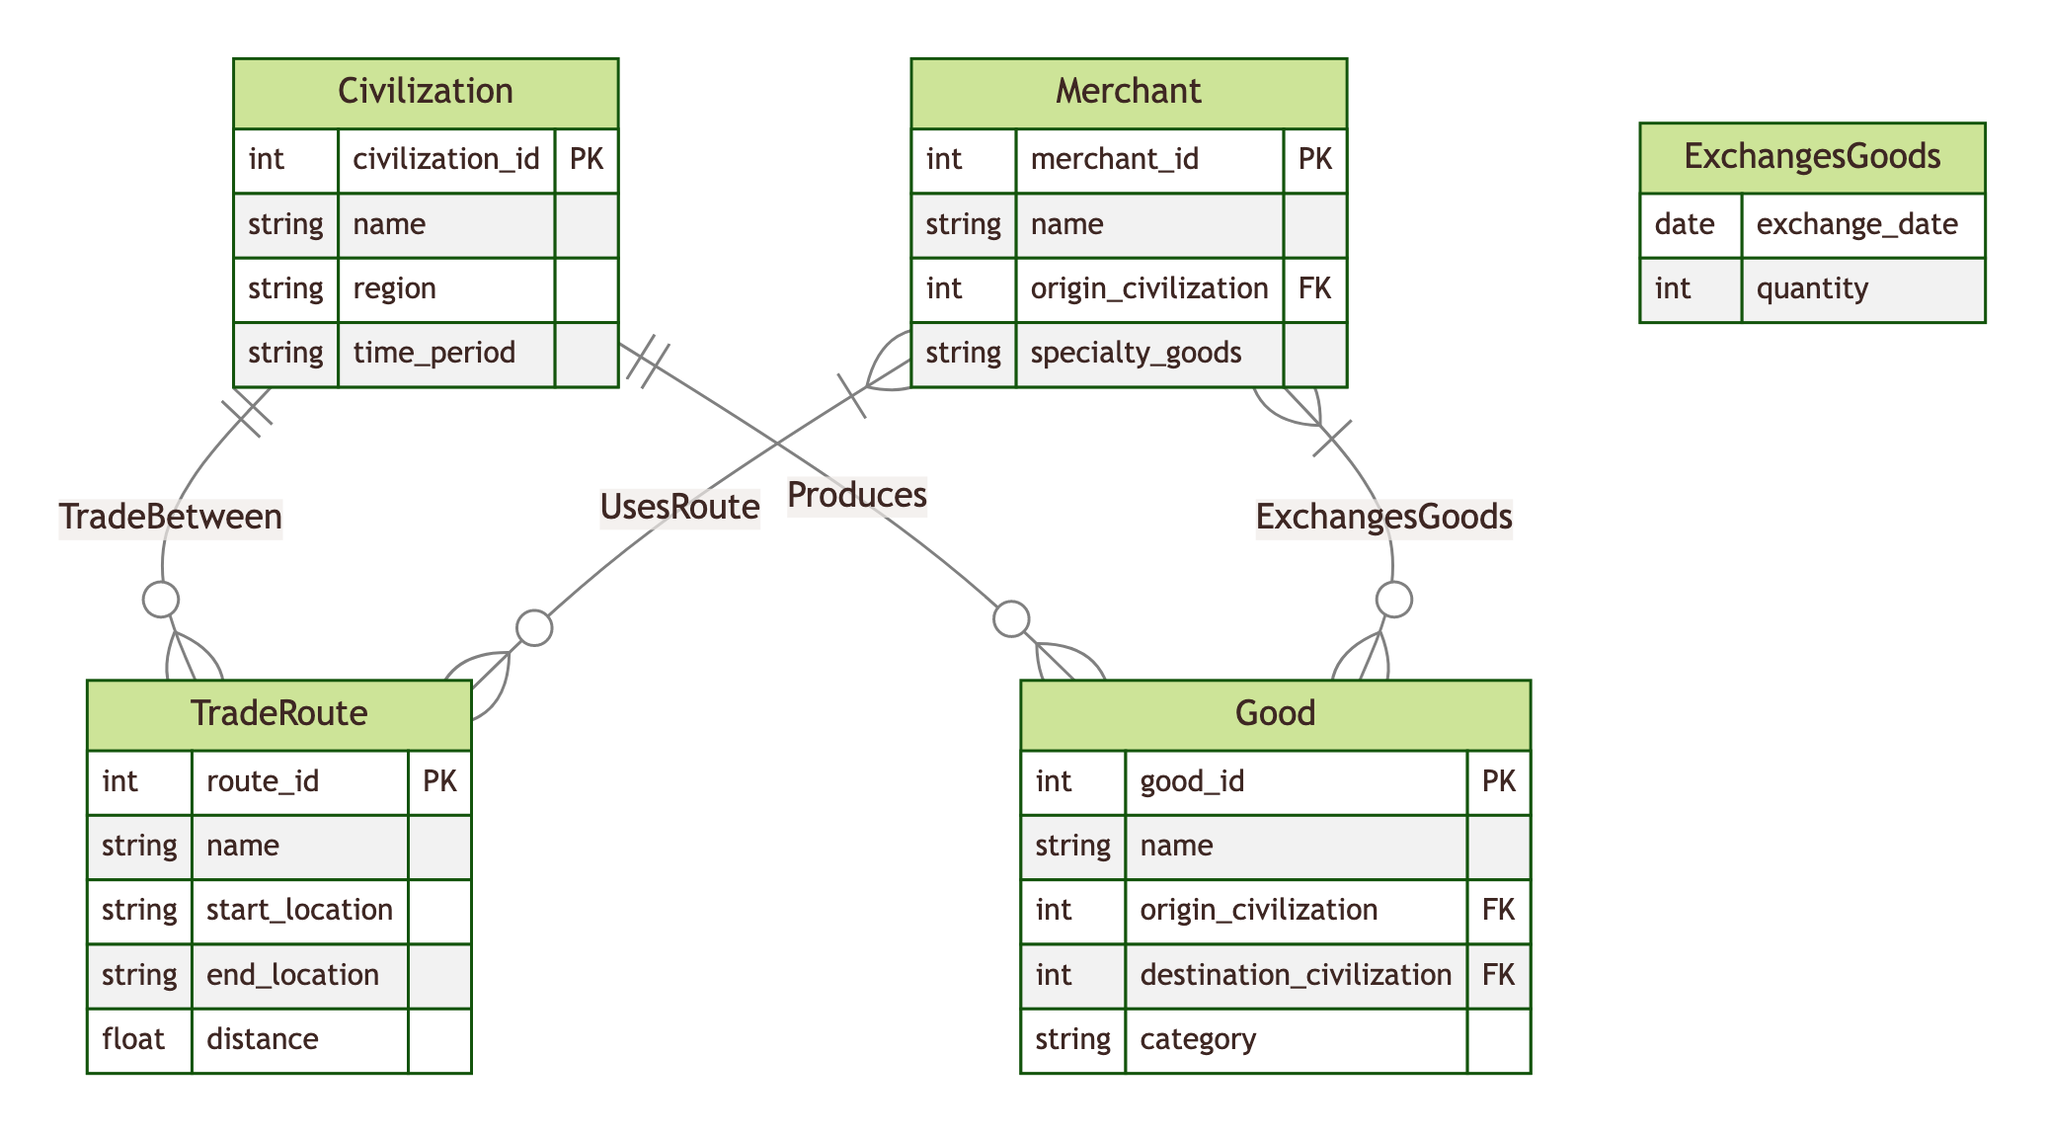What entities are present in the diagram? The diagram contains four entities: Civilization, TradeRoute, Merchant, and Good.
Answer: Civilization, TradeRoute, Merchant, Good What is the primary key of the Merchant entity? Looking at the diagram, the primary key of the Merchant entity is merchant_id.
Answer: merchant_id How many relationships are defined in the diagram? The diagram outlines four relationships: UsesRoute, ExchangesGoods, TradeBetween, and Produces.
Answer: Four Which entity is connected to the Good entity via the Produces relationship? The Produces relationship connects the Civilization entity to the Good entity.
Answer: Civilization What attributes does the TradeRoute entity have? The TradeRoute entity has attributes: route_id, name, start_location, end_location, and distance.
Answer: route_id, name, start_location, end_location, distance How does a Merchant interact with TradeRoutes? A Merchant uses various TradeRoutes, as indicated by the UsesRoute relationship connecting the Merchant and TradeRoute entities.
Answer: UsesRoute What is the exchange relationship that connects Merchant and Good? The relationship is called ExchangesGoods, which links the Merchant entity with the Good entity.
Answer: ExchangesGoods Which two entities have a direct connection to the Good entity? The Good entity is directly connected to the Merchant and Civilization entities through the ExchangesGoods and Produces relationships, respectively.
Answer: Merchant, Civilization In what relationship does a Merchant exchange goods? A Merchant exchanges goods through the ExchangesGoods relationship.
Answer: ExchangesGoods 